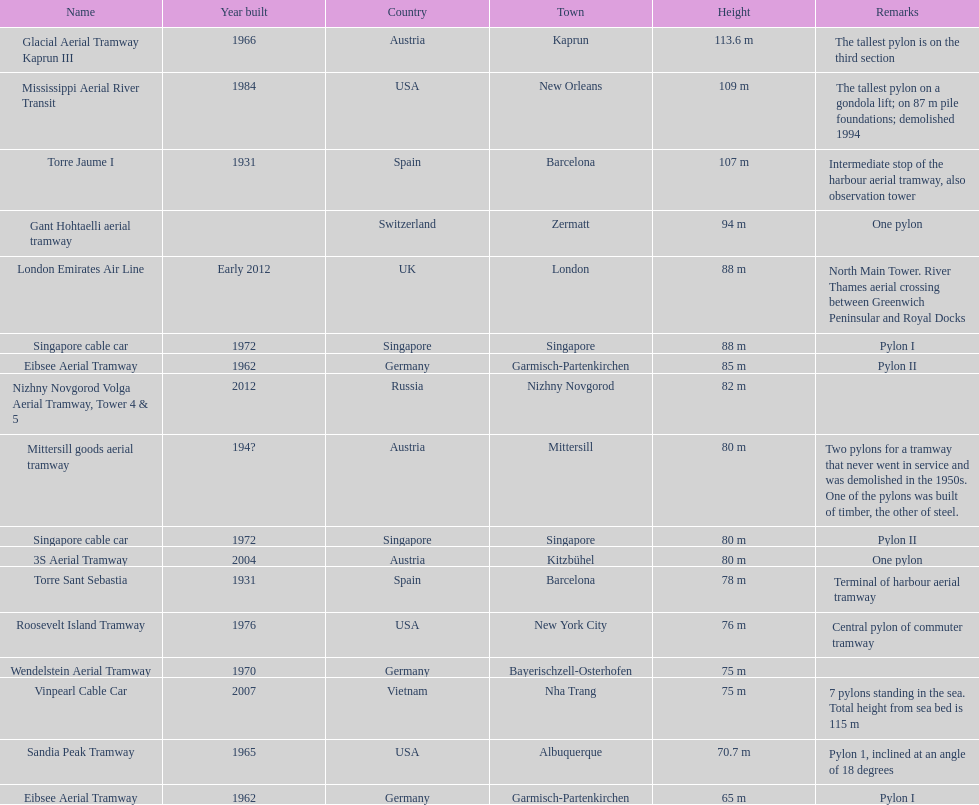What is the pylon with the least height listed here? Eibsee Aerial Tramway. 